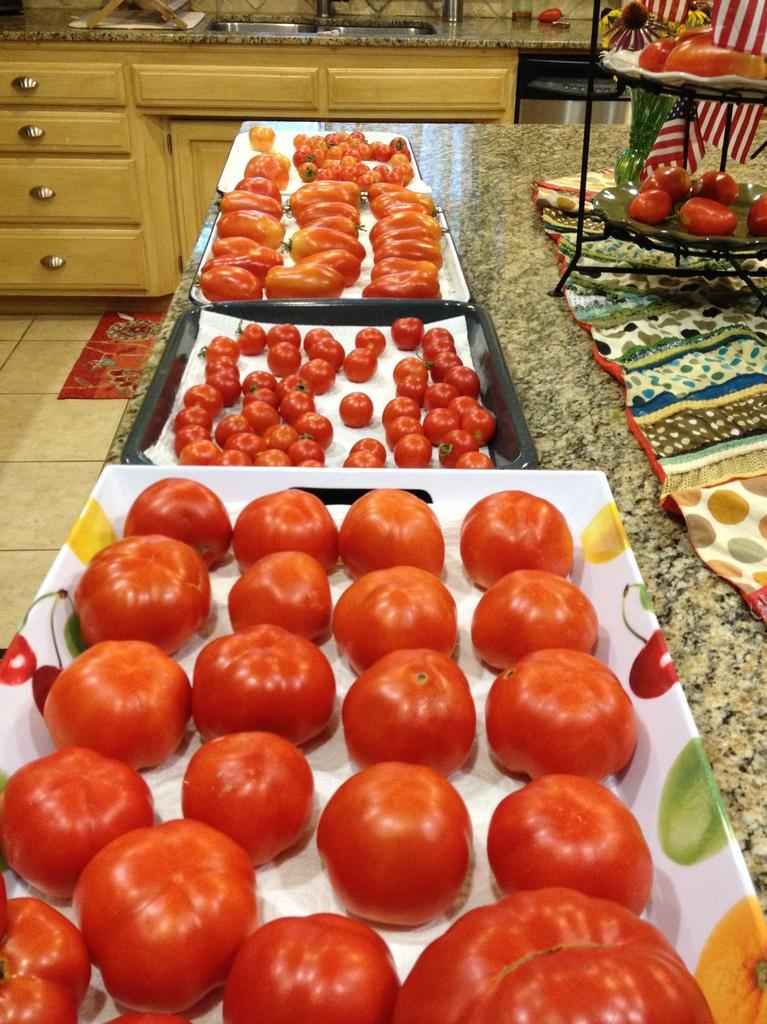What type of food items are present in the image? There are tomatoes in the image. How are the tomatoes arranged or placed? The tomatoes are placed on trays. Where are the trays with tomatoes located? The trays are kept on a kitchen platform. How does the door affect the tomatoes on the trays in the image? There is no door present in the image, so it cannot affect the tomatoes on the trays. 